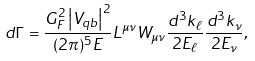Convert formula to latex. <formula><loc_0><loc_0><loc_500><loc_500>d \Gamma = \frac { G _ { F } ^ { 2 } \left | V _ { q b } \right | ^ { 2 } } { ( 2 \pi ) ^ { 5 } E } L ^ { \mu \nu } W _ { \mu \nu } \frac { d ^ { 3 } k _ { \ell } } { 2 E _ { \ell } } \frac { d ^ { 3 } k _ { \nu } } { 2 E _ { \nu } } ,</formula> 